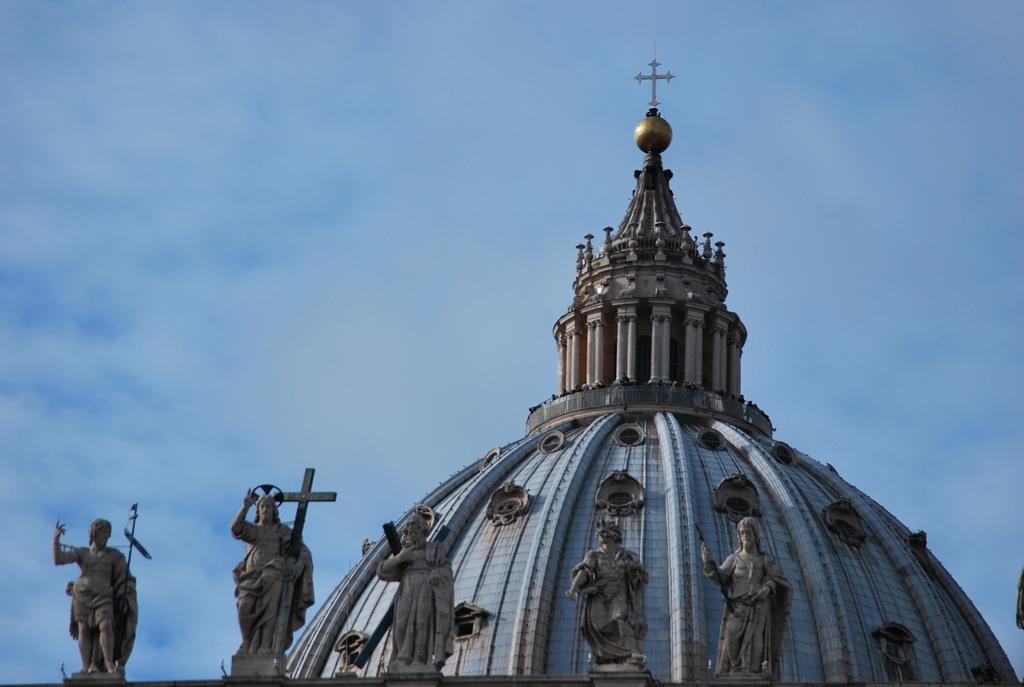Describe this image in one or two sentences. In this image we can see top of a building with pillars. Also there are statues. In the background there is sky with clouds. 